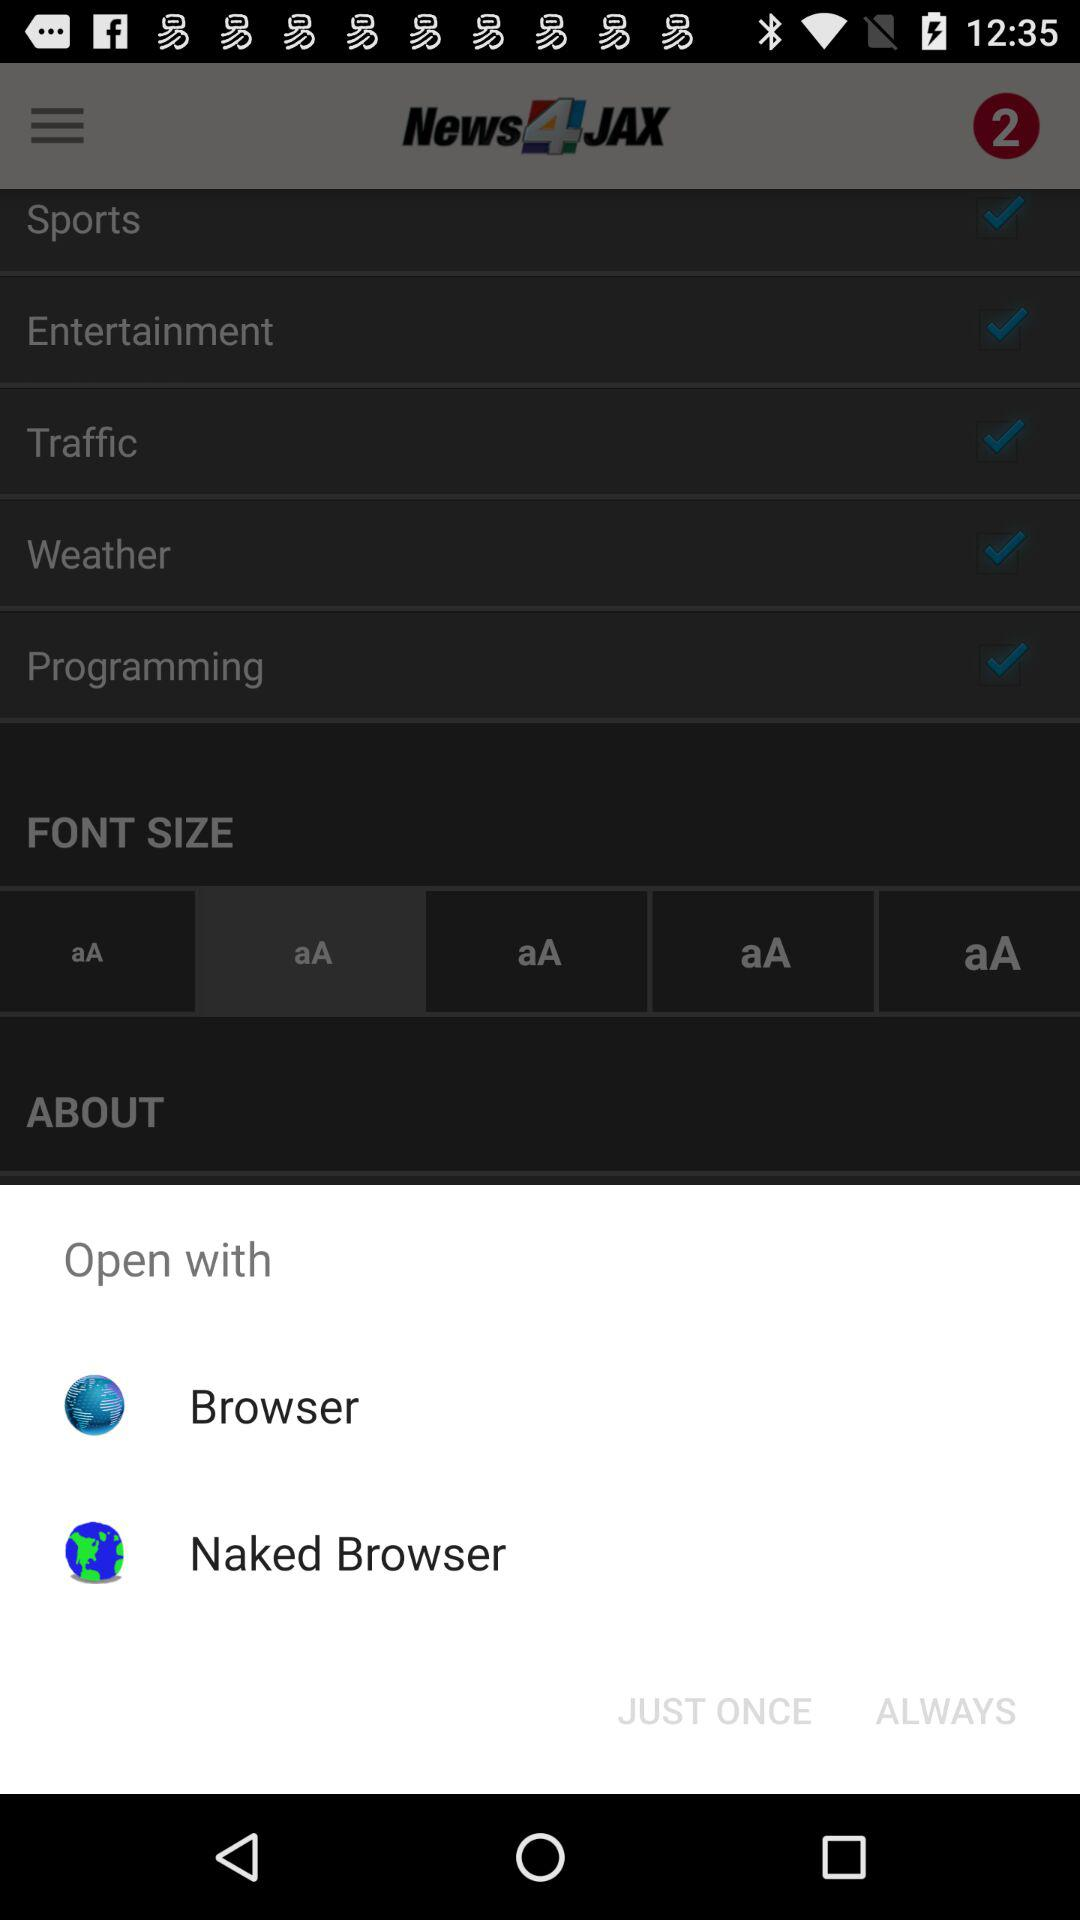What is selected in "Weather"?
When the provided information is insufficient, respond with <no answer>. <no answer> 